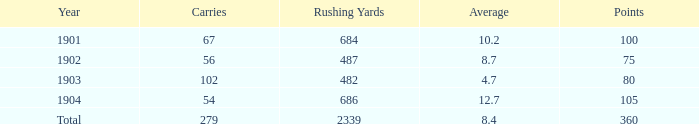How many carries possess an average less than 8.7 and have scored 72 touchdowns? 1.0. 